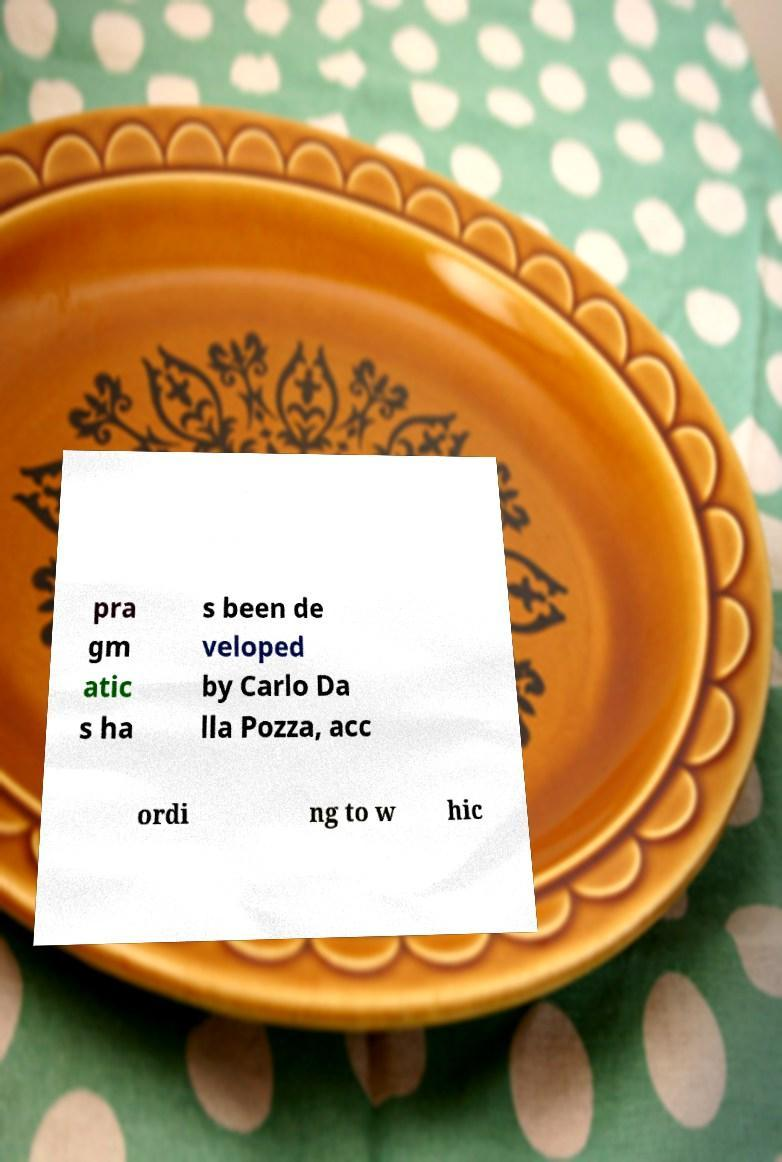For documentation purposes, I need the text within this image transcribed. Could you provide that? pra gm atic s ha s been de veloped by Carlo Da lla Pozza, acc ordi ng to w hic 